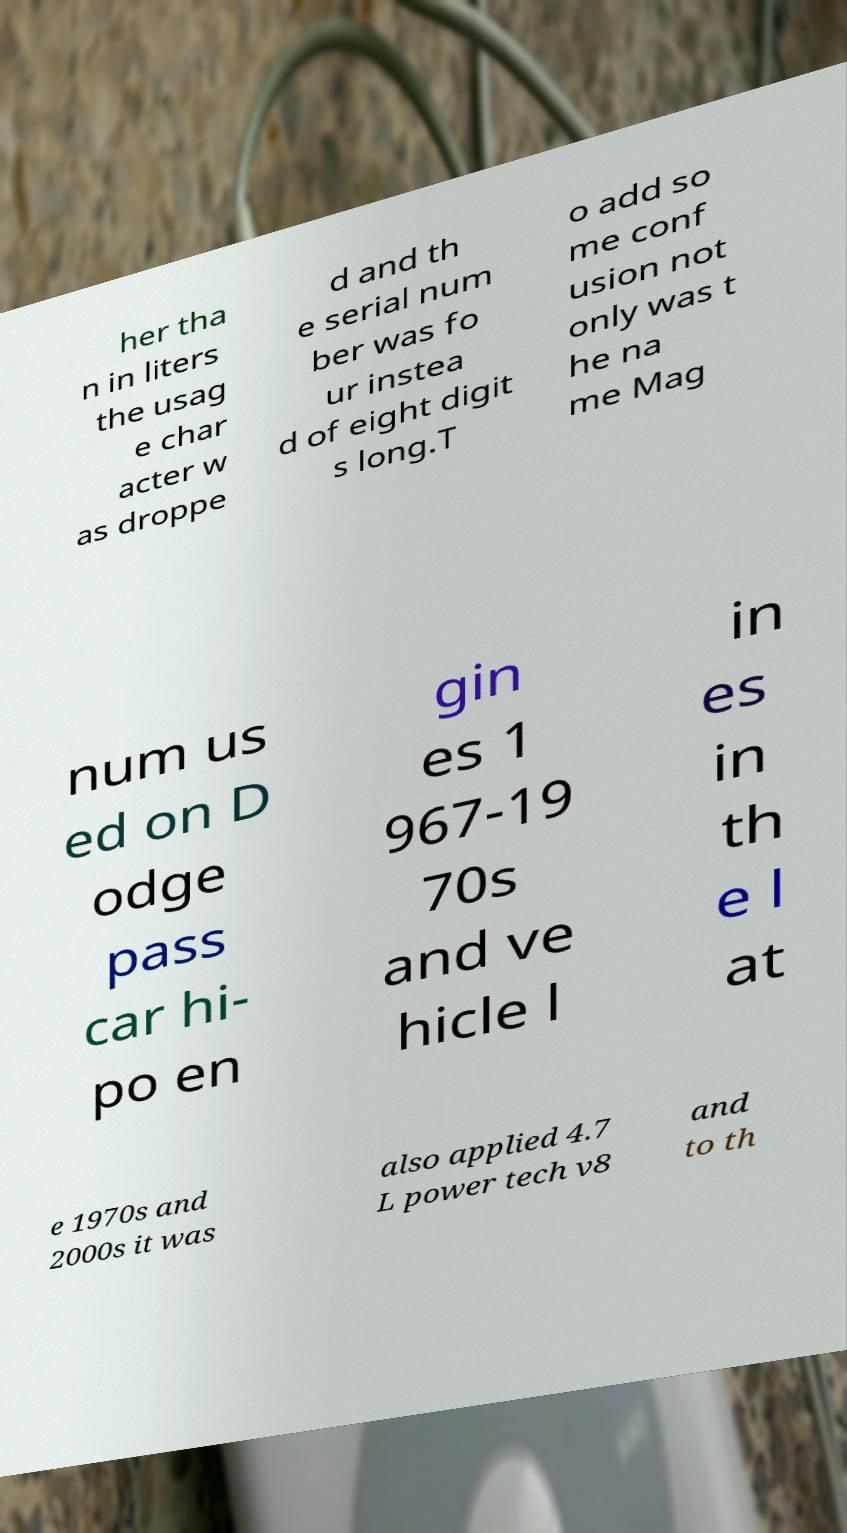Please identify and transcribe the text found in this image. her tha n in liters the usag e char acter w as droppe d and th e serial num ber was fo ur instea d of eight digit s long.T o add so me conf usion not only was t he na me Mag num us ed on D odge pass car hi- po en gin es 1 967-19 70s and ve hicle l in es in th e l at e 1970s and 2000s it was also applied 4.7 L power tech v8 and to th 